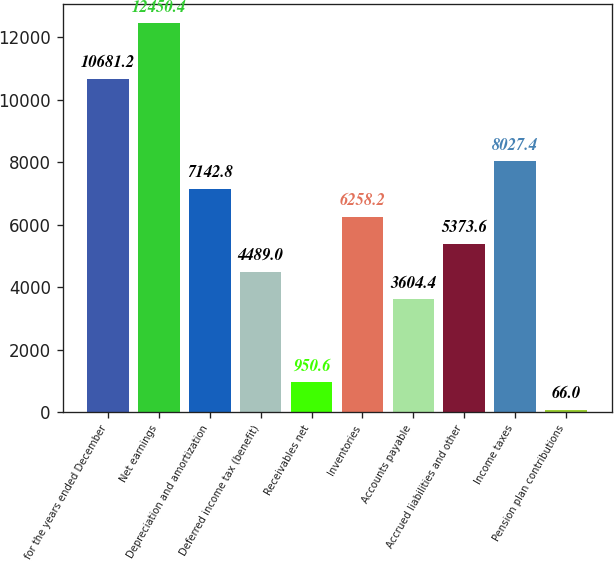Convert chart to OTSL. <chart><loc_0><loc_0><loc_500><loc_500><bar_chart><fcel>for the years ended December<fcel>Net earnings<fcel>Depreciation and amortization<fcel>Deferred income tax (benefit)<fcel>Receivables net<fcel>Inventories<fcel>Accounts payable<fcel>Accrued liabilities and other<fcel>Income taxes<fcel>Pension plan contributions<nl><fcel>10681.2<fcel>12450.4<fcel>7142.8<fcel>4489<fcel>950.6<fcel>6258.2<fcel>3604.4<fcel>5373.6<fcel>8027.4<fcel>66<nl></chart> 